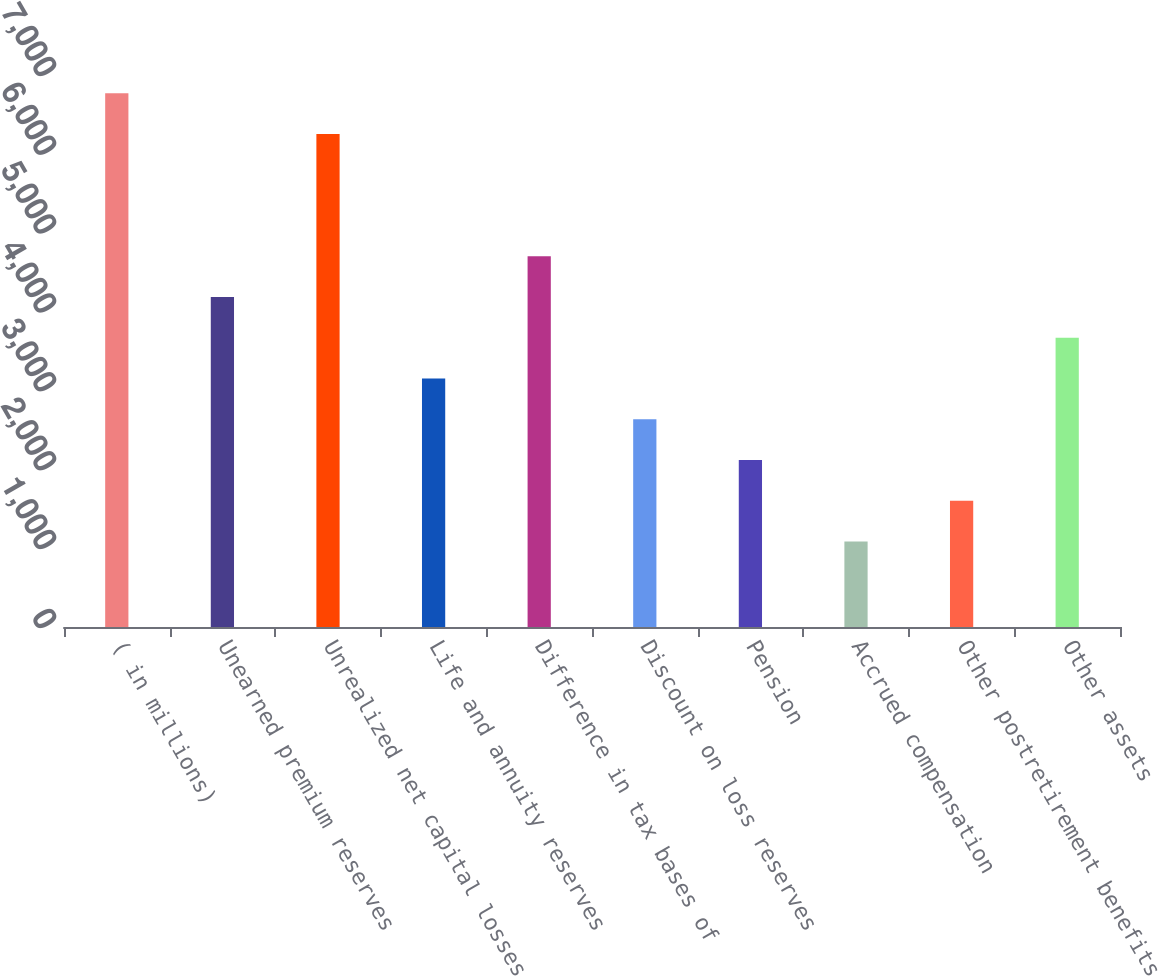Convert chart to OTSL. <chart><loc_0><loc_0><loc_500><loc_500><bar_chart><fcel>( in millions)<fcel>Unearned premium reserves<fcel>Unrealized net capital losses<fcel>Life and annuity reserves<fcel>Difference in tax bases of<fcel>Discount on loss reserves<fcel>Pension<fcel>Accrued compensation<fcel>Other postretirement benefits<fcel>Other assets<nl><fcel>6768.7<fcel>4184.2<fcel>6251.8<fcel>3150.4<fcel>4701.1<fcel>2633.5<fcel>2116.6<fcel>1082.8<fcel>1599.7<fcel>3667.3<nl></chart> 